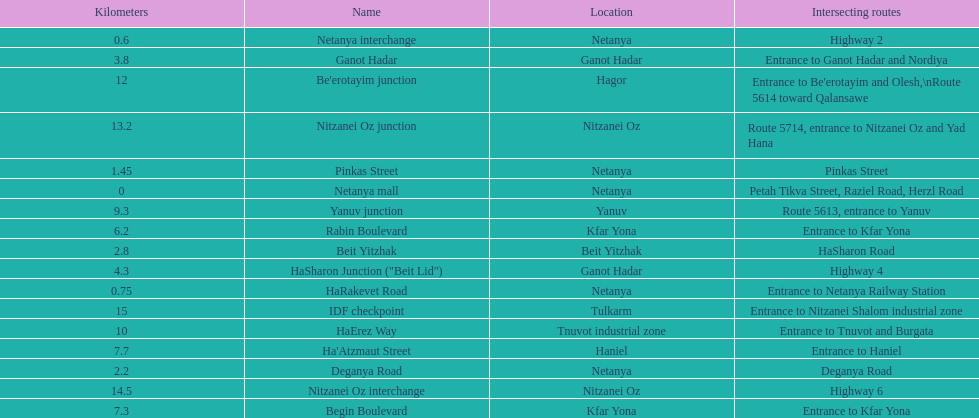How many sections intersect highway 2? 1. 